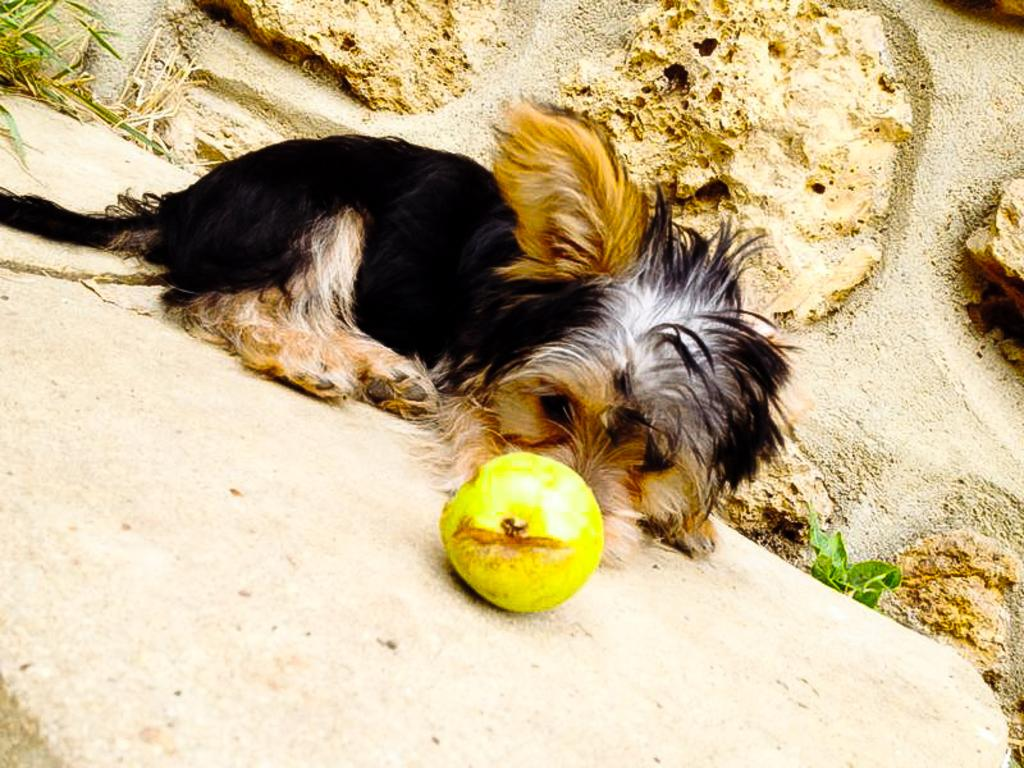What type of animal is in the image? There is a dog in the image. What is the dog doing in the image? The dog is laying on the ground. What is in front of the dog in the image? There is a fruit in front of the dog. What type of beast is present in the image? There is no beast present in the image; it features a dog. What type of spark can be seen coming from the dog's fur in the image? There is no spark present in the image; the dog is simply laying on the ground with a fruit in front of it. 